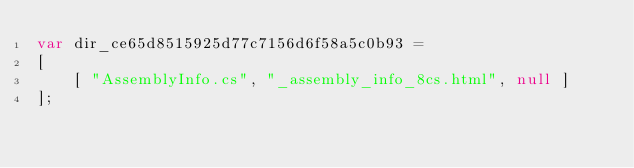<code> <loc_0><loc_0><loc_500><loc_500><_JavaScript_>var dir_ce65d8515925d77c7156d6f58a5c0b93 =
[
    [ "AssemblyInfo.cs", "_assembly_info_8cs.html", null ]
];</code> 